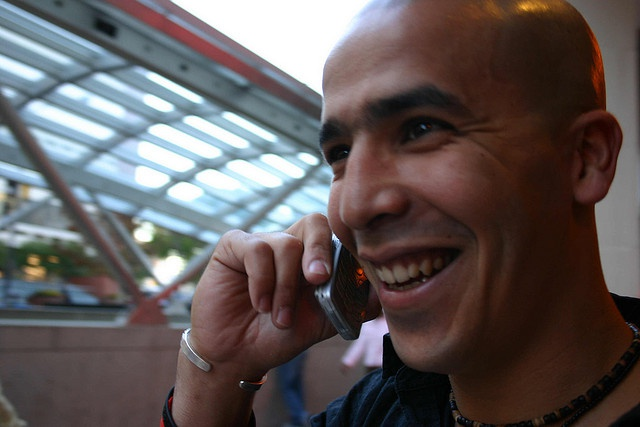Describe the objects in this image and their specific colors. I can see people in gray, black, maroon, and brown tones and cell phone in gray, black, and maroon tones in this image. 